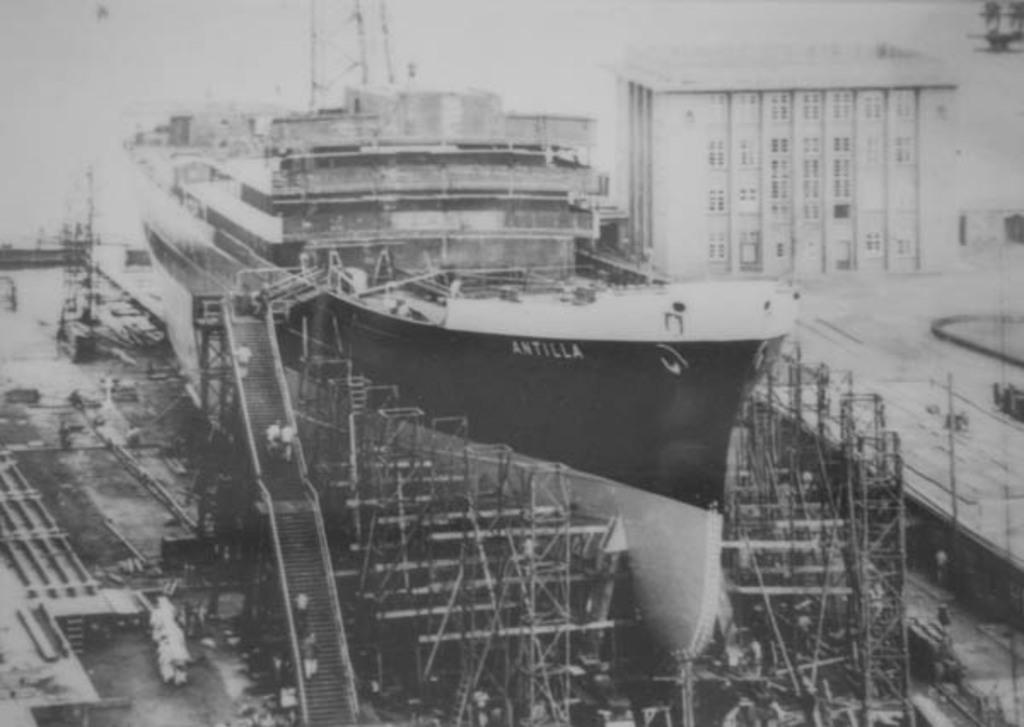<image>
Offer a succinct explanation of the picture presented. Construction for a ship with ANTILLA written on the side. 